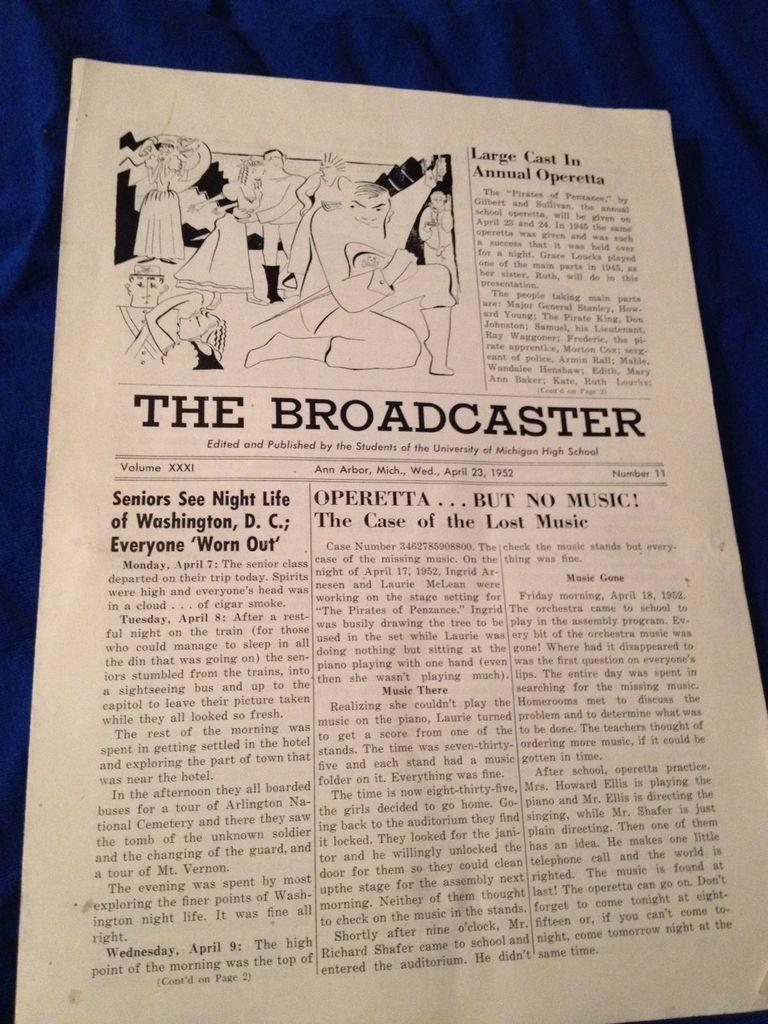<image>
Offer a succinct explanation of the picture presented. Volume XXXI of The Broadcaster published by students of University of Michigan High School. 